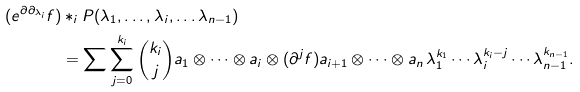<formula> <loc_0><loc_0><loc_500><loc_500>( e ^ { \partial \partial _ { \lambda _ { i } } } f ) & * _ { i } P ( \lambda _ { 1 } , \dots , \lambda _ { i } , \dots \lambda _ { n - 1 } ) \\ & = \sum \sum ^ { k _ { i } } _ { j = 0 } \binom { k _ { i } } { j } a _ { 1 } \otimes \cdots \otimes a _ { i } \otimes ( \partial ^ { j } f ) a _ { i + 1 } \otimes \cdots \otimes a _ { n } \, \lambda ^ { k _ { 1 } } _ { 1 } \cdots \lambda ^ { k _ { i } - j } _ { i } \cdots \lambda ^ { k _ { n - 1 } } _ { n - 1 } .</formula> 